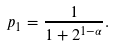Convert formula to latex. <formula><loc_0><loc_0><loc_500><loc_500>p _ { 1 } = \frac { 1 } { 1 + 2 ^ { 1 - \alpha } } .</formula> 